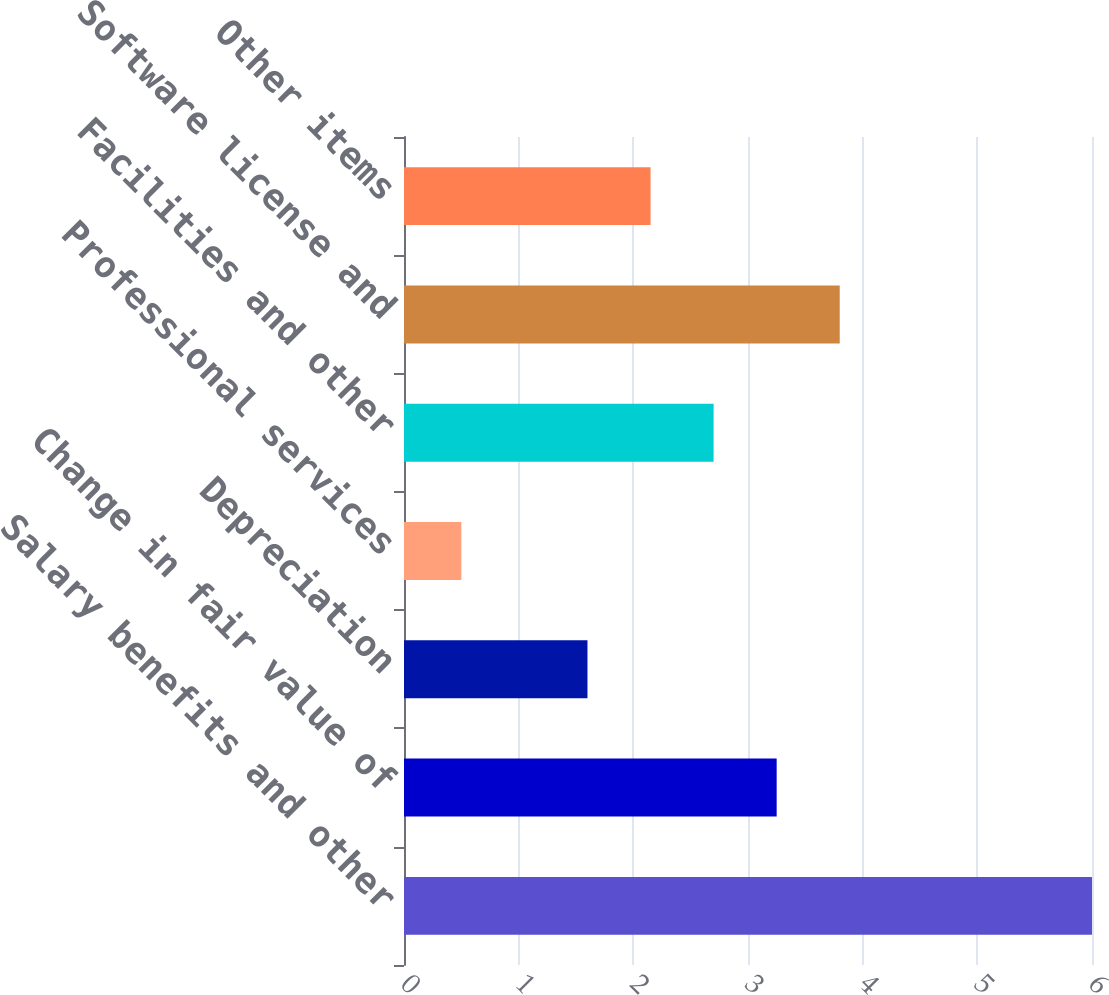<chart> <loc_0><loc_0><loc_500><loc_500><bar_chart><fcel>Salary benefits and other<fcel>Change in fair value of<fcel>Depreciation<fcel>Professional services<fcel>Facilities and other<fcel>Software license and<fcel>Other items<nl><fcel>6<fcel>3.25<fcel>1.6<fcel>0.5<fcel>2.7<fcel>3.8<fcel>2.15<nl></chart> 